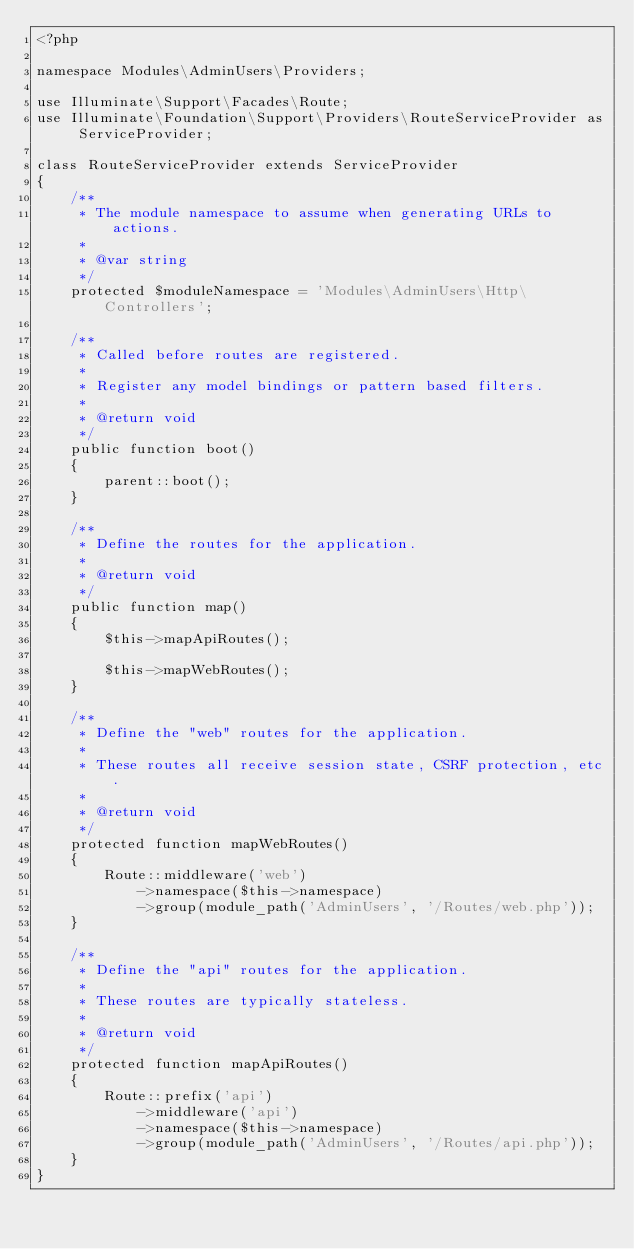Convert code to text. <code><loc_0><loc_0><loc_500><loc_500><_PHP_><?php

namespace Modules\AdminUsers\Providers;

use Illuminate\Support\Facades\Route;
use Illuminate\Foundation\Support\Providers\RouteServiceProvider as ServiceProvider;

class RouteServiceProvider extends ServiceProvider
{
    /**
     * The module namespace to assume when generating URLs to actions.
     *
     * @var string
     */
    protected $moduleNamespace = 'Modules\AdminUsers\Http\Controllers';

    /**
     * Called before routes are registered.
     *
     * Register any model bindings or pattern based filters.
     *
     * @return void
     */
    public function boot()
    {
        parent::boot();
    }

    /**
     * Define the routes for the application.
     *
     * @return void
     */
    public function map()
    {
        $this->mapApiRoutes();

        $this->mapWebRoutes();
    }

    /**
     * Define the "web" routes for the application.
     *
     * These routes all receive session state, CSRF protection, etc.
     *
     * @return void
     */
    protected function mapWebRoutes()
    {
        Route::middleware('web')
            ->namespace($this->namespace)
            ->group(module_path('AdminUsers', '/Routes/web.php'));
    }

    /**
     * Define the "api" routes for the application.
     *
     * These routes are typically stateless.
     *
     * @return void
     */
    protected function mapApiRoutes()
    {
        Route::prefix('api')
            ->middleware('api')
            ->namespace($this->namespace)
            ->group(module_path('AdminUsers', '/Routes/api.php'));
    }
}
</code> 